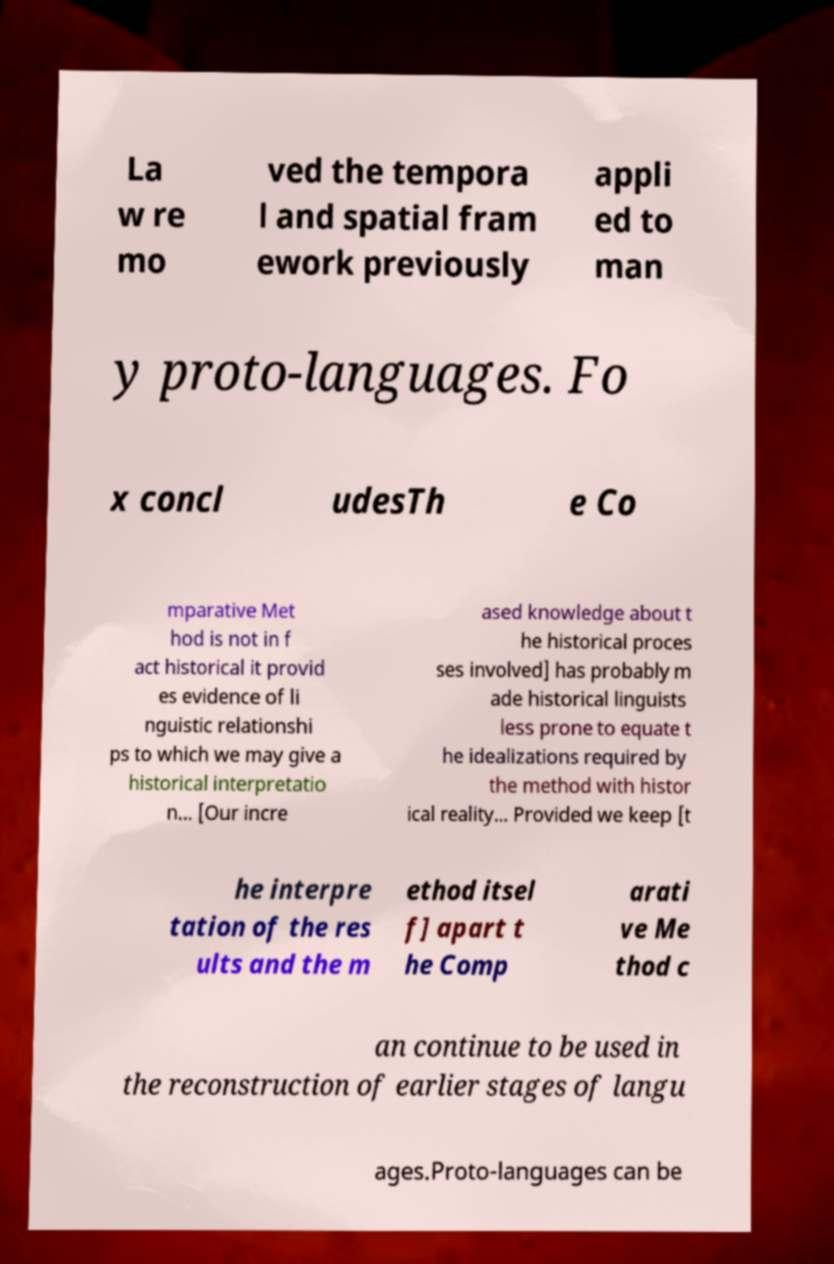Could you assist in decoding the text presented in this image and type it out clearly? La w re mo ved the tempora l and spatial fram ework previously appli ed to man y proto-languages. Fo x concl udesTh e Co mparative Met hod is not in f act historical it provid es evidence of li nguistic relationshi ps to which we may give a historical interpretatio n... [Our incre ased knowledge about t he historical proces ses involved] has probably m ade historical linguists less prone to equate t he idealizations required by the method with histor ical reality... Provided we keep [t he interpre tation of the res ults and the m ethod itsel f] apart t he Comp arati ve Me thod c an continue to be used in the reconstruction of earlier stages of langu ages.Proto-languages can be 